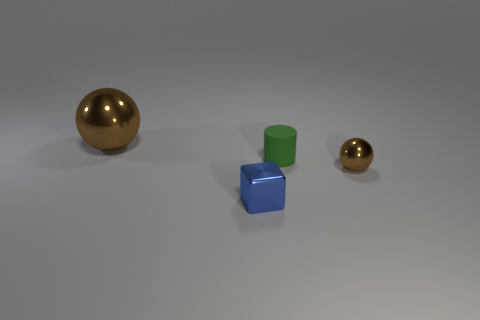Add 1 small blue shiny cubes. How many objects exist? 5 Subtract all cubes. How many objects are left? 3 Subtract all cyan blocks. Subtract all yellow balls. How many blocks are left? 1 Subtract all small green spheres. Subtract all brown things. How many objects are left? 2 Add 1 blue metallic objects. How many blue metallic objects are left? 2 Add 1 shiny spheres. How many shiny spheres exist? 3 Subtract 0 yellow cubes. How many objects are left? 4 